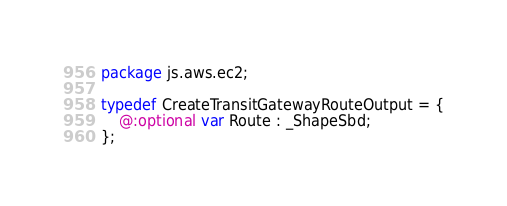Convert code to text. <code><loc_0><loc_0><loc_500><loc_500><_Haxe_>package js.aws.ec2;

typedef CreateTransitGatewayRouteOutput = {
    @:optional var Route : _ShapeSbd;
};
</code> 